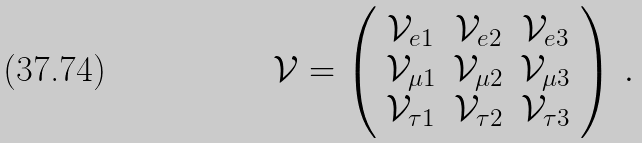Convert formula to latex. <formula><loc_0><loc_0><loc_500><loc_500>\mathcal { V } = \left ( \begin{array} { c c c } \mathcal { V } _ { e 1 } & \mathcal { V } _ { e 2 } & \mathcal { V } _ { e 3 } \\ \mathcal { V } _ { \mu 1 } & \mathcal { V } _ { \mu 2 } & \mathcal { V } _ { \mu 3 } \\ \mathcal { V } _ { \tau 1 } & \mathcal { V } _ { \tau 2 } & \mathcal { V } _ { \tau 3 } \end{array} \right ) \, .</formula> 